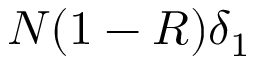<formula> <loc_0><loc_0><loc_500><loc_500>N ( 1 - R ) \delta _ { 1 }</formula> 